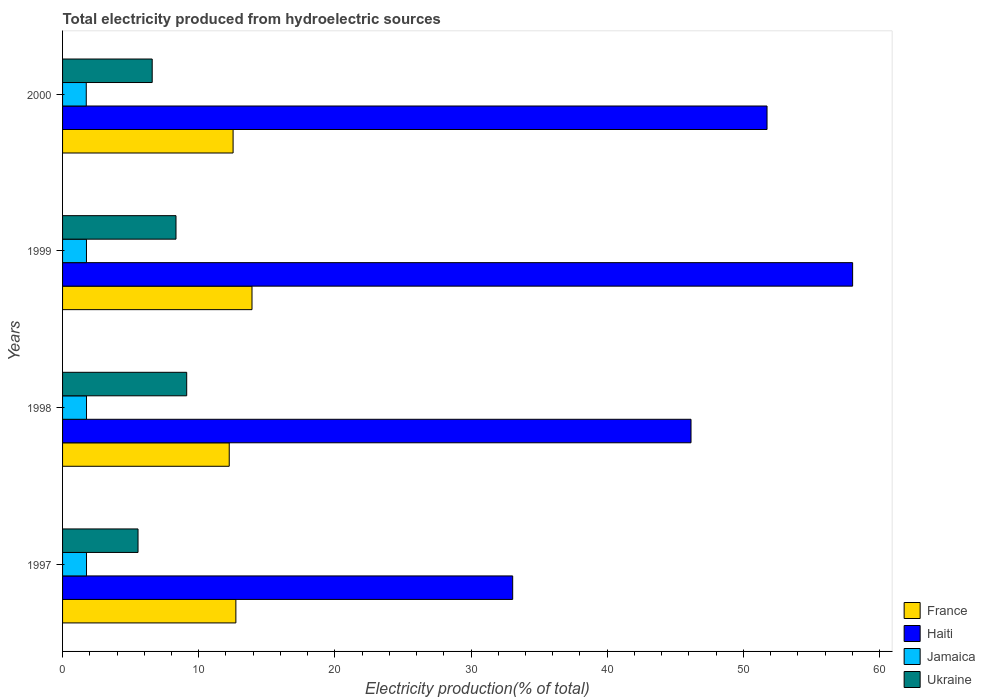Are the number of bars on each tick of the Y-axis equal?
Provide a succinct answer. Yes. What is the label of the 4th group of bars from the top?
Keep it short and to the point. 1997. What is the total electricity produced in Jamaica in 1999?
Offer a very short reply. 1.76. Across all years, what is the maximum total electricity produced in France?
Give a very brief answer. 13.91. Across all years, what is the minimum total electricity produced in France?
Make the answer very short. 12.24. In which year was the total electricity produced in France maximum?
Provide a succinct answer. 1999. In which year was the total electricity produced in Jamaica minimum?
Make the answer very short. 2000. What is the total total electricity produced in Haiti in the graph?
Make the answer very short. 188.97. What is the difference between the total electricity produced in Haiti in 1997 and that in 1999?
Provide a short and direct response. -24.97. What is the difference between the total electricity produced in Ukraine in 1997 and the total electricity produced in France in 1999?
Your response must be concise. -8.37. What is the average total electricity produced in Haiti per year?
Offer a very short reply. 47.24. In the year 1998, what is the difference between the total electricity produced in Jamaica and total electricity produced in Haiti?
Offer a very short reply. -44.39. What is the ratio of the total electricity produced in Ukraine in 1997 to that in 2000?
Ensure brevity in your answer.  0.84. Is the difference between the total electricity produced in Jamaica in 1998 and 2000 greater than the difference between the total electricity produced in Haiti in 1998 and 2000?
Make the answer very short. Yes. What is the difference between the highest and the second highest total electricity produced in Ukraine?
Your answer should be very brief. 0.79. What is the difference between the highest and the lowest total electricity produced in Jamaica?
Provide a succinct answer. 0.02. In how many years, is the total electricity produced in Jamaica greater than the average total electricity produced in Jamaica taken over all years?
Provide a succinct answer. 3. Is the sum of the total electricity produced in Haiti in 1999 and 2000 greater than the maximum total electricity produced in France across all years?
Keep it short and to the point. Yes. What does the 1st bar from the top in 2000 represents?
Make the answer very short. Ukraine. What does the 4th bar from the bottom in 1998 represents?
Your response must be concise. Ukraine. Where does the legend appear in the graph?
Give a very brief answer. Bottom right. What is the title of the graph?
Offer a very short reply. Total electricity produced from hydroelectric sources. Does "Thailand" appear as one of the legend labels in the graph?
Your answer should be very brief. No. What is the label or title of the X-axis?
Your answer should be very brief. Electricity production(% of total). What is the label or title of the Y-axis?
Your answer should be very brief. Years. What is the Electricity production(% of total) in France in 1997?
Your response must be concise. 12.73. What is the Electricity production(% of total) in Haiti in 1997?
Keep it short and to the point. 33.06. What is the Electricity production(% of total) in Jamaica in 1997?
Make the answer very short. 1.76. What is the Electricity production(% of total) of Ukraine in 1997?
Provide a succinct answer. 5.54. What is the Electricity production(% of total) of France in 1998?
Ensure brevity in your answer.  12.24. What is the Electricity production(% of total) in Haiti in 1998?
Keep it short and to the point. 46.15. What is the Electricity production(% of total) of Jamaica in 1998?
Your answer should be compact. 1.76. What is the Electricity production(% of total) in Ukraine in 1998?
Your answer should be compact. 9.12. What is the Electricity production(% of total) in France in 1999?
Your response must be concise. 13.91. What is the Electricity production(% of total) of Haiti in 1999?
Ensure brevity in your answer.  58.02. What is the Electricity production(% of total) of Jamaica in 1999?
Give a very brief answer. 1.76. What is the Electricity production(% of total) of Ukraine in 1999?
Your answer should be very brief. 8.33. What is the Electricity production(% of total) of France in 2000?
Make the answer very short. 12.52. What is the Electricity production(% of total) of Haiti in 2000?
Your answer should be very brief. 51.74. What is the Electricity production(% of total) of Jamaica in 2000?
Offer a very short reply. 1.74. What is the Electricity production(% of total) of Ukraine in 2000?
Keep it short and to the point. 6.58. Across all years, what is the maximum Electricity production(% of total) in France?
Provide a succinct answer. 13.91. Across all years, what is the maximum Electricity production(% of total) of Haiti?
Keep it short and to the point. 58.02. Across all years, what is the maximum Electricity production(% of total) in Jamaica?
Offer a very short reply. 1.76. Across all years, what is the maximum Electricity production(% of total) of Ukraine?
Your response must be concise. 9.12. Across all years, what is the minimum Electricity production(% of total) of France?
Provide a short and direct response. 12.24. Across all years, what is the minimum Electricity production(% of total) in Haiti?
Offer a very short reply. 33.06. Across all years, what is the minimum Electricity production(% of total) of Jamaica?
Offer a very short reply. 1.74. Across all years, what is the minimum Electricity production(% of total) in Ukraine?
Give a very brief answer. 5.54. What is the total Electricity production(% of total) of France in the graph?
Your answer should be compact. 51.4. What is the total Electricity production(% of total) of Haiti in the graph?
Offer a very short reply. 188.97. What is the total Electricity production(% of total) in Jamaica in the graph?
Ensure brevity in your answer.  7.01. What is the total Electricity production(% of total) of Ukraine in the graph?
Provide a succinct answer. 29.57. What is the difference between the Electricity production(% of total) of France in 1997 and that in 1998?
Your answer should be compact. 0.49. What is the difference between the Electricity production(% of total) in Haiti in 1997 and that in 1998?
Offer a very short reply. -13.1. What is the difference between the Electricity production(% of total) in Jamaica in 1997 and that in 1998?
Make the answer very short. -0. What is the difference between the Electricity production(% of total) of Ukraine in 1997 and that in 1998?
Your response must be concise. -3.57. What is the difference between the Electricity production(% of total) of France in 1997 and that in 1999?
Your answer should be compact. -1.18. What is the difference between the Electricity production(% of total) of Haiti in 1997 and that in 1999?
Your answer should be very brief. -24.97. What is the difference between the Electricity production(% of total) in Jamaica in 1997 and that in 1999?
Your answer should be compact. 0. What is the difference between the Electricity production(% of total) of Ukraine in 1997 and that in 1999?
Provide a short and direct response. -2.79. What is the difference between the Electricity production(% of total) in France in 1997 and that in 2000?
Ensure brevity in your answer.  0.2. What is the difference between the Electricity production(% of total) in Haiti in 1997 and that in 2000?
Your response must be concise. -18.68. What is the difference between the Electricity production(% of total) of Jamaica in 1997 and that in 2000?
Your answer should be compact. 0.02. What is the difference between the Electricity production(% of total) of Ukraine in 1997 and that in 2000?
Your answer should be very brief. -1.04. What is the difference between the Electricity production(% of total) of France in 1998 and that in 1999?
Make the answer very short. -1.67. What is the difference between the Electricity production(% of total) in Haiti in 1998 and that in 1999?
Your response must be concise. -11.87. What is the difference between the Electricity production(% of total) of Jamaica in 1998 and that in 1999?
Offer a terse response. 0. What is the difference between the Electricity production(% of total) in Ukraine in 1998 and that in 1999?
Offer a terse response. 0.79. What is the difference between the Electricity production(% of total) in France in 1998 and that in 2000?
Provide a succinct answer. -0.28. What is the difference between the Electricity production(% of total) of Haiti in 1998 and that in 2000?
Ensure brevity in your answer.  -5.58. What is the difference between the Electricity production(% of total) of Jamaica in 1998 and that in 2000?
Make the answer very short. 0.02. What is the difference between the Electricity production(% of total) in Ukraine in 1998 and that in 2000?
Make the answer very short. 2.53. What is the difference between the Electricity production(% of total) in France in 1999 and that in 2000?
Your answer should be compact. 1.39. What is the difference between the Electricity production(% of total) of Haiti in 1999 and that in 2000?
Ensure brevity in your answer.  6.29. What is the difference between the Electricity production(% of total) of Jamaica in 1999 and that in 2000?
Give a very brief answer. 0.01. What is the difference between the Electricity production(% of total) in Ukraine in 1999 and that in 2000?
Your response must be concise. 1.75. What is the difference between the Electricity production(% of total) of France in 1997 and the Electricity production(% of total) of Haiti in 1998?
Offer a terse response. -33.43. What is the difference between the Electricity production(% of total) of France in 1997 and the Electricity production(% of total) of Jamaica in 1998?
Give a very brief answer. 10.97. What is the difference between the Electricity production(% of total) of France in 1997 and the Electricity production(% of total) of Ukraine in 1998?
Provide a succinct answer. 3.61. What is the difference between the Electricity production(% of total) of Haiti in 1997 and the Electricity production(% of total) of Jamaica in 1998?
Your answer should be compact. 31.3. What is the difference between the Electricity production(% of total) in Haiti in 1997 and the Electricity production(% of total) in Ukraine in 1998?
Ensure brevity in your answer.  23.94. What is the difference between the Electricity production(% of total) in Jamaica in 1997 and the Electricity production(% of total) in Ukraine in 1998?
Your answer should be compact. -7.36. What is the difference between the Electricity production(% of total) in France in 1997 and the Electricity production(% of total) in Haiti in 1999?
Provide a succinct answer. -45.3. What is the difference between the Electricity production(% of total) of France in 1997 and the Electricity production(% of total) of Jamaica in 1999?
Provide a short and direct response. 10.97. What is the difference between the Electricity production(% of total) in France in 1997 and the Electricity production(% of total) in Ukraine in 1999?
Your answer should be very brief. 4.4. What is the difference between the Electricity production(% of total) in Haiti in 1997 and the Electricity production(% of total) in Jamaica in 1999?
Keep it short and to the point. 31.3. What is the difference between the Electricity production(% of total) of Haiti in 1997 and the Electricity production(% of total) of Ukraine in 1999?
Give a very brief answer. 24.73. What is the difference between the Electricity production(% of total) in Jamaica in 1997 and the Electricity production(% of total) in Ukraine in 1999?
Provide a succinct answer. -6.57. What is the difference between the Electricity production(% of total) in France in 1997 and the Electricity production(% of total) in Haiti in 2000?
Offer a very short reply. -39.01. What is the difference between the Electricity production(% of total) in France in 1997 and the Electricity production(% of total) in Jamaica in 2000?
Provide a short and direct response. 10.99. What is the difference between the Electricity production(% of total) of France in 1997 and the Electricity production(% of total) of Ukraine in 2000?
Your response must be concise. 6.15. What is the difference between the Electricity production(% of total) in Haiti in 1997 and the Electricity production(% of total) in Jamaica in 2000?
Make the answer very short. 31.32. What is the difference between the Electricity production(% of total) in Haiti in 1997 and the Electricity production(% of total) in Ukraine in 2000?
Your answer should be compact. 26.48. What is the difference between the Electricity production(% of total) of Jamaica in 1997 and the Electricity production(% of total) of Ukraine in 2000?
Provide a short and direct response. -4.82. What is the difference between the Electricity production(% of total) in France in 1998 and the Electricity production(% of total) in Haiti in 1999?
Your answer should be compact. -45.78. What is the difference between the Electricity production(% of total) of France in 1998 and the Electricity production(% of total) of Jamaica in 1999?
Offer a terse response. 10.49. What is the difference between the Electricity production(% of total) in France in 1998 and the Electricity production(% of total) in Ukraine in 1999?
Your response must be concise. 3.91. What is the difference between the Electricity production(% of total) of Haiti in 1998 and the Electricity production(% of total) of Jamaica in 1999?
Offer a terse response. 44.4. What is the difference between the Electricity production(% of total) in Haiti in 1998 and the Electricity production(% of total) in Ukraine in 1999?
Give a very brief answer. 37.82. What is the difference between the Electricity production(% of total) in Jamaica in 1998 and the Electricity production(% of total) in Ukraine in 1999?
Your answer should be compact. -6.57. What is the difference between the Electricity production(% of total) of France in 1998 and the Electricity production(% of total) of Haiti in 2000?
Offer a very short reply. -39.5. What is the difference between the Electricity production(% of total) in France in 1998 and the Electricity production(% of total) in Jamaica in 2000?
Offer a very short reply. 10.5. What is the difference between the Electricity production(% of total) in France in 1998 and the Electricity production(% of total) in Ukraine in 2000?
Ensure brevity in your answer.  5.66. What is the difference between the Electricity production(% of total) in Haiti in 1998 and the Electricity production(% of total) in Jamaica in 2000?
Your answer should be very brief. 44.41. What is the difference between the Electricity production(% of total) in Haiti in 1998 and the Electricity production(% of total) in Ukraine in 2000?
Offer a very short reply. 39.57. What is the difference between the Electricity production(% of total) of Jamaica in 1998 and the Electricity production(% of total) of Ukraine in 2000?
Your answer should be compact. -4.82. What is the difference between the Electricity production(% of total) of France in 1999 and the Electricity production(% of total) of Haiti in 2000?
Make the answer very short. -37.82. What is the difference between the Electricity production(% of total) of France in 1999 and the Electricity production(% of total) of Jamaica in 2000?
Offer a terse response. 12.17. What is the difference between the Electricity production(% of total) of France in 1999 and the Electricity production(% of total) of Ukraine in 2000?
Your answer should be very brief. 7.33. What is the difference between the Electricity production(% of total) in Haiti in 1999 and the Electricity production(% of total) in Jamaica in 2000?
Keep it short and to the point. 56.28. What is the difference between the Electricity production(% of total) in Haiti in 1999 and the Electricity production(% of total) in Ukraine in 2000?
Give a very brief answer. 51.44. What is the difference between the Electricity production(% of total) of Jamaica in 1999 and the Electricity production(% of total) of Ukraine in 2000?
Your response must be concise. -4.83. What is the average Electricity production(% of total) of France per year?
Make the answer very short. 12.85. What is the average Electricity production(% of total) in Haiti per year?
Provide a succinct answer. 47.24. What is the average Electricity production(% of total) of Jamaica per year?
Your response must be concise. 1.75. What is the average Electricity production(% of total) in Ukraine per year?
Your answer should be very brief. 7.39. In the year 1997, what is the difference between the Electricity production(% of total) in France and Electricity production(% of total) in Haiti?
Your response must be concise. -20.33. In the year 1997, what is the difference between the Electricity production(% of total) in France and Electricity production(% of total) in Jamaica?
Your answer should be compact. 10.97. In the year 1997, what is the difference between the Electricity production(% of total) of France and Electricity production(% of total) of Ukraine?
Ensure brevity in your answer.  7.19. In the year 1997, what is the difference between the Electricity production(% of total) in Haiti and Electricity production(% of total) in Jamaica?
Provide a short and direct response. 31.3. In the year 1997, what is the difference between the Electricity production(% of total) of Haiti and Electricity production(% of total) of Ukraine?
Ensure brevity in your answer.  27.52. In the year 1997, what is the difference between the Electricity production(% of total) in Jamaica and Electricity production(% of total) in Ukraine?
Provide a short and direct response. -3.78. In the year 1998, what is the difference between the Electricity production(% of total) of France and Electricity production(% of total) of Haiti?
Provide a succinct answer. -33.91. In the year 1998, what is the difference between the Electricity production(% of total) in France and Electricity production(% of total) in Jamaica?
Keep it short and to the point. 10.48. In the year 1998, what is the difference between the Electricity production(% of total) in France and Electricity production(% of total) in Ukraine?
Your answer should be compact. 3.12. In the year 1998, what is the difference between the Electricity production(% of total) of Haiti and Electricity production(% of total) of Jamaica?
Offer a terse response. 44.39. In the year 1998, what is the difference between the Electricity production(% of total) in Haiti and Electricity production(% of total) in Ukraine?
Offer a very short reply. 37.04. In the year 1998, what is the difference between the Electricity production(% of total) of Jamaica and Electricity production(% of total) of Ukraine?
Provide a short and direct response. -7.36. In the year 1999, what is the difference between the Electricity production(% of total) in France and Electricity production(% of total) in Haiti?
Your answer should be compact. -44.11. In the year 1999, what is the difference between the Electricity production(% of total) of France and Electricity production(% of total) of Jamaica?
Your answer should be compact. 12.16. In the year 1999, what is the difference between the Electricity production(% of total) in France and Electricity production(% of total) in Ukraine?
Provide a succinct answer. 5.58. In the year 1999, what is the difference between the Electricity production(% of total) of Haiti and Electricity production(% of total) of Jamaica?
Your answer should be compact. 56.27. In the year 1999, what is the difference between the Electricity production(% of total) of Haiti and Electricity production(% of total) of Ukraine?
Provide a short and direct response. 49.69. In the year 1999, what is the difference between the Electricity production(% of total) in Jamaica and Electricity production(% of total) in Ukraine?
Offer a very short reply. -6.58. In the year 2000, what is the difference between the Electricity production(% of total) in France and Electricity production(% of total) in Haiti?
Give a very brief answer. -39.21. In the year 2000, what is the difference between the Electricity production(% of total) in France and Electricity production(% of total) in Jamaica?
Offer a very short reply. 10.78. In the year 2000, what is the difference between the Electricity production(% of total) of France and Electricity production(% of total) of Ukraine?
Give a very brief answer. 5.94. In the year 2000, what is the difference between the Electricity production(% of total) in Haiti and Electricity production(% of total) in Jamaica?
Provide a short and direct response. 50. In the year 2000, what is the difference between the Electricity production(% of total) in Haiti and Electricity production(% of total) in Ukraine?
Your response must be concise. 45.15. In the year 2000, what is the difference between the Electricity production(% of total) in Jamaica and Electricity production(% of total) in Ukraine?
Make the answer very short. -4.84. What is the ratio of the Electricity production(% of total) of France in 1997 to that in 1998?
Provide a succinct answer. 1.04. What is the ratio of the Electricity production(% of total) in Haiti in 1997 to that in 1998?
Ensure brevity in your answer.  0.72. What is the ratio of the Electricity production(% of total) in Ukraine in 1997 to that in 1998?
Give a very brief answer. 0.61. What is the ratio of the Electricity production(% of total) in France in 1997 to that in 1999?
Provide a short and direct response. 0.91. What is the ratio of the Electricity production(% of total) in Haiti in 1997 to that in 1999?
Give a very brief answer. 0.57. What is the ratio of the Electricity production(% of total) of Ukraine in 1997 to that in 1999?
Your response must be concise. 0.67. What is the ratio of the Electricity production(% of total) of France in 1997 to that in 2000?
Provide a succinct answer. 1.02. What is the ratio of the Electricity production(% of total) in Haiti in 1997 to that in 2000?
Your answer should be very brief. 0.64. What is the ratio of the Electricity production(% of total) in Jamaica in 1997 to that in 2000?
Your answer should be very brief. 1.01. What is the ratio of the Electricity production(% of total) of Ukraine in 1997 to that in 2000?
Provide a short and direct response. 0.84. What is the ratio of the Electricity production(% of total) in France in 1998 to that in 1999?
Your response must be concise. 0.88. What is the ratio of the Electricity production(% of total) of Haiti in 1998 to that in 1999?
Provide a succinct answer. 0.8. What is the ratio of the Electricity production(% of total) of Ukraine in 1998 to that in 1999?
Make the answer very short. 1.09. What is the ratio of the Electricity production(% of total) of France in 1998 to that in 2000?
Make the answer very short. 0.98. What is the ratio of the Electricity production(% of total) in Haiti in 1998 to that in 2000?
Give a very brief answer. 0.89. What is the ratio of the Electricity production(% of total) in Jamaica in 1998 to that in 2000?
Make the answer very short. 1.01. What is the ratio of the Electricity production(% of total) in Ukraine in 1998 to that in 2000?
Give a very brief answer. 1.38. What is the ratio of the Electricity production(% of total) of France in 1999 to that in 2000?
Provide a short and direct response. 1.11. What is the ratio of the Electricity production(% of total) in Haiti in 1999 to that in 2000?
Ensure brevity in your answer.  1.12. What is the ratio of the Electricity production(% of total) in Jamaica in 1999 to that in 2000?
Give a very brief answer. 1.01. What is the ratio of the Electricity production(% of total) of Ukraine in 1999 to that in 2000?
Give a very brief answer. 1.27. What is the difference between the highest and the second highest Electricity production(% of total) in France?
Keep it short and to the point. 1.18. What is the difference between the highest and the second highest Electricity production(% of total) in Haiti?
Your answer should be compact. 6.29. What is the difference between the highest and the second highest Electricity production(% of total) in Jamaica?
Make the answer very short. 0. What is the difference between the highest and the second highest Electricity production(% of total) of Ukraine?
Offer a terse response. 0.79. What is the difference between the highest and the lowest Electricity production(% of total) in France?
Ensure brevity in your answer.  1.67. What is the difference between the highest and the lowest Electricity production(% of total) in Haiti?
Offer a very short reply. 24.97. What is the difference between the highest and the lowest Electricity production(% of total) of Jamaica?
Offer a terse response. 0.02. What is the difference between the highest and the lowest Electricity production(% of total) of Ukraine?
Keep it short and to the point. 3.57. 